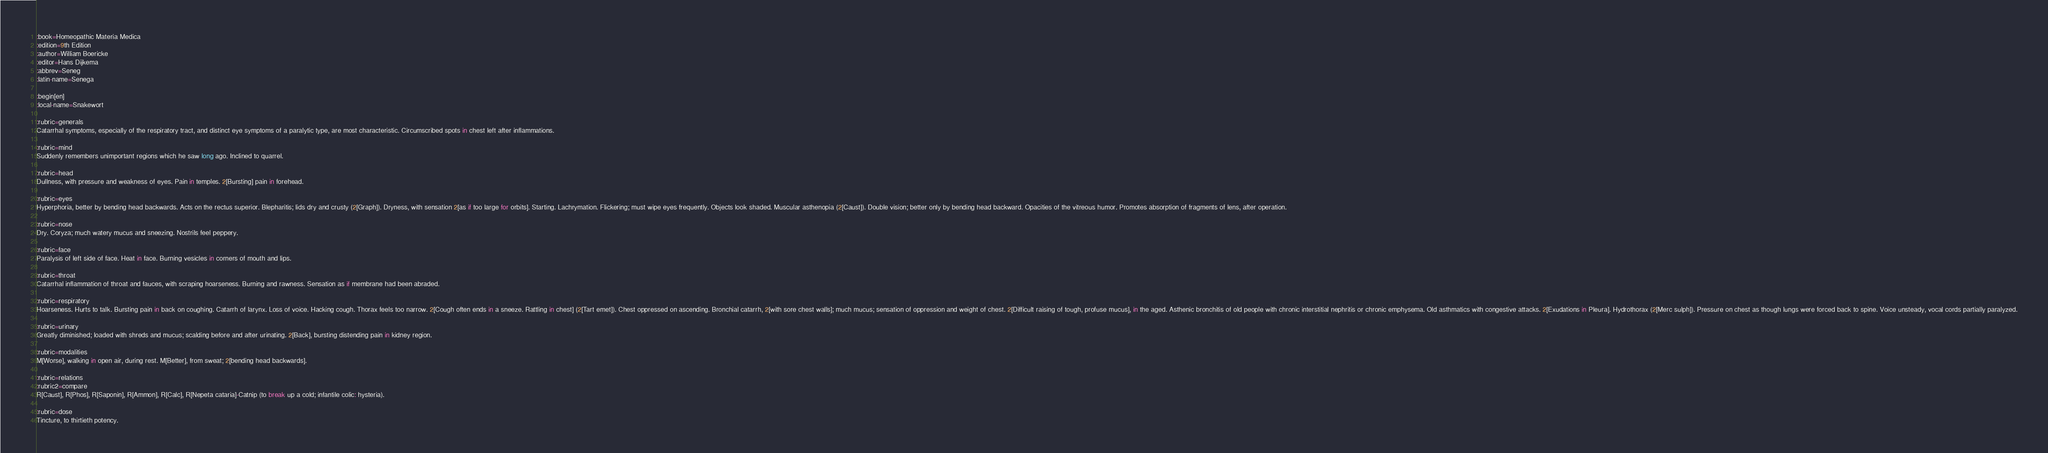Convert code to text. <code><loc_0><loc_0><loc_500><loc_500><_ObjectiveC_>:book=Homeopathic Materia Medica
:edition=9th Edition
:author=William Boericke
:editor=Hans Dijkema
:abbrev=Seneg
:latin-name=Senega

:begin[en]
:local-name=Snakewort

:rubric=generals
Catarrhal symptoms, especially of the respiratory tract, and distinct eye symptoms of a paralytic type, are most characteristic. Circumscribed spots in chest left after inflammations.

:rubric=mind
Suddenly remembers unimportant regions which he saw long ago. Inclined to quarrel.

:rubric=head
Dullness, with pressure and weakness of eyes. Pain in temples. 2[Bursting] pain in forehead.

:rubric=eyes
Hyperphoria, better by bending head backwards. Acts on the rectus superior. Blepharitis; lids dry and crusty (2[Graph]). Dryness, with sensation 2[as if too large for orbits]. Starting. Lachrymation. Flickering; must wipe eyes frequently. Objects look shaded. Muscular asthenopia (2[Caust]). Double vision; better only by bending head backward. Opacities of the vitreous humor. Promotes absorption of fragments of lens, after operation.

:rubric=nose
Dry. Coryza; much watery mucus and sneezing. Nostrils feel peppery.

:rubric=face
Paralysis of left side of face. Heat in face. Burning vesicles in corners of mouth and lips.

:rubric=throat
Catarrhal inflammation of throat and fauces, with scraping hoarseness. Burning and rawness. Sensation as if membrane had been abraded.

:rubric=respiratory
Hoarseness. Hurts to talk. Bursting pain in back on coughing. Catarrh of larynx. Loss of voice. Hacking cough. Thorax feels too narrow. 2[Cough often ends in a sneeze. Rattling in chest] (2[Tart emet]). Chest oppressed on ascending. Bronchial catarrh, 2[with sore chest walls]; much mucus; sensation of oppression and weight of chest. 2[Difficult raising of tough, profuse mucus], in the aged. Asthenic bronchitis of old people with chronic interstitial nephritis or chronic emphysema. Old asthmatics with congestive attacks. 2[Exudations in Pleura]. Hydrothorax (2[Merc sulph]). Pressure on chest as though lungs were forced back to spine. Voice unsteady, vocal cords partially paralyzed.

:rubric=urinary
Greatly diminished; loaded with shreds and mucus; scalding before and after urinating. 2[Back], bursting distending pain in kidney region.

:rubric=modalities
M[Worse], walking in open air, during rest. M[Better], from sweat; 2[bending head backwards].

:rubric=relations
:rubric2=compare
R[Caust], R[Phos], R[Saponin], R[Ammon], R[Calc], R[Nepeta cataria]-Catnip (to break up a cold; infantile colic: hysteria).

:rubric=dose
Tincture, to thirtieth potency.

</code> 